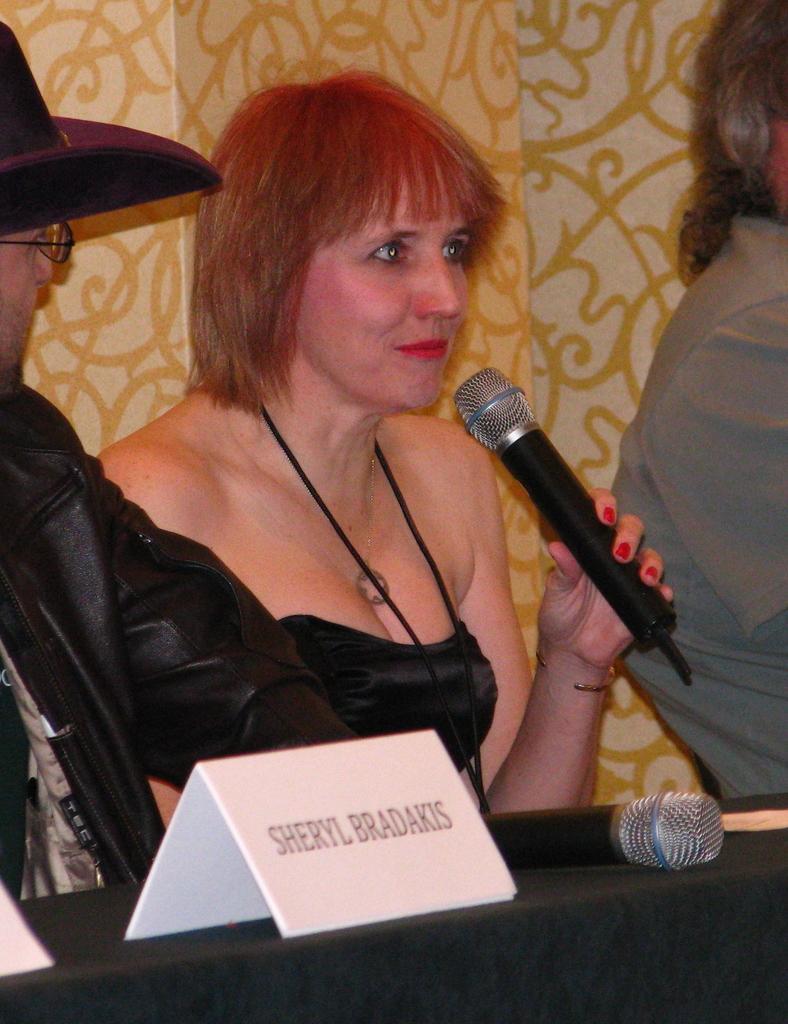How would you summarize this image in a sentence or two? It is a closed room where the woman is sitting on the chair wearing a black dress and holding a microphone and beside her there is a one person wearing a black jacket and hat, in front of him there is one name plate and a microphone present on the table and behind them there is a curtain. 